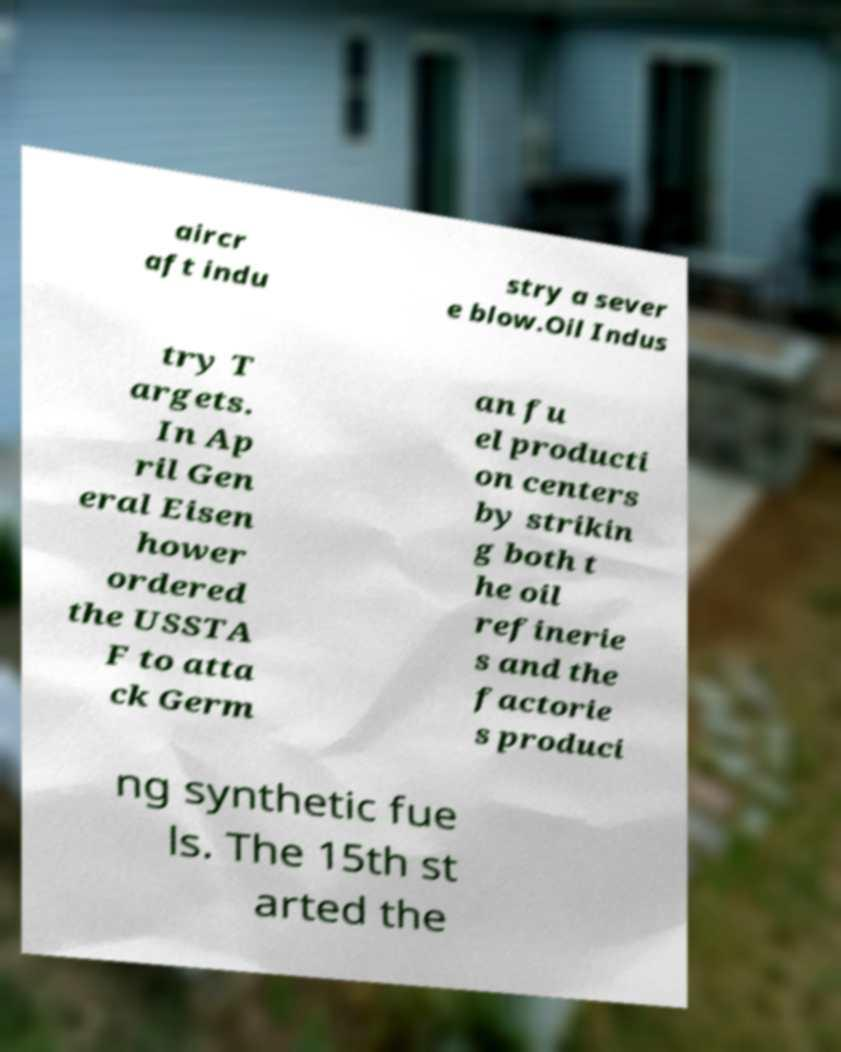Could you extract and type out the text from this image? aircr aft indu stry a sever e blow.Oil Indus try T argets. In Ap ril Gen eral Eisen hower ordered the USSTA F to atta ck Germ an fu el producti on centers by strikin g both t he oil refinerie s and the factorie s produci ng synthetic fue ls. The 15th st arted the 